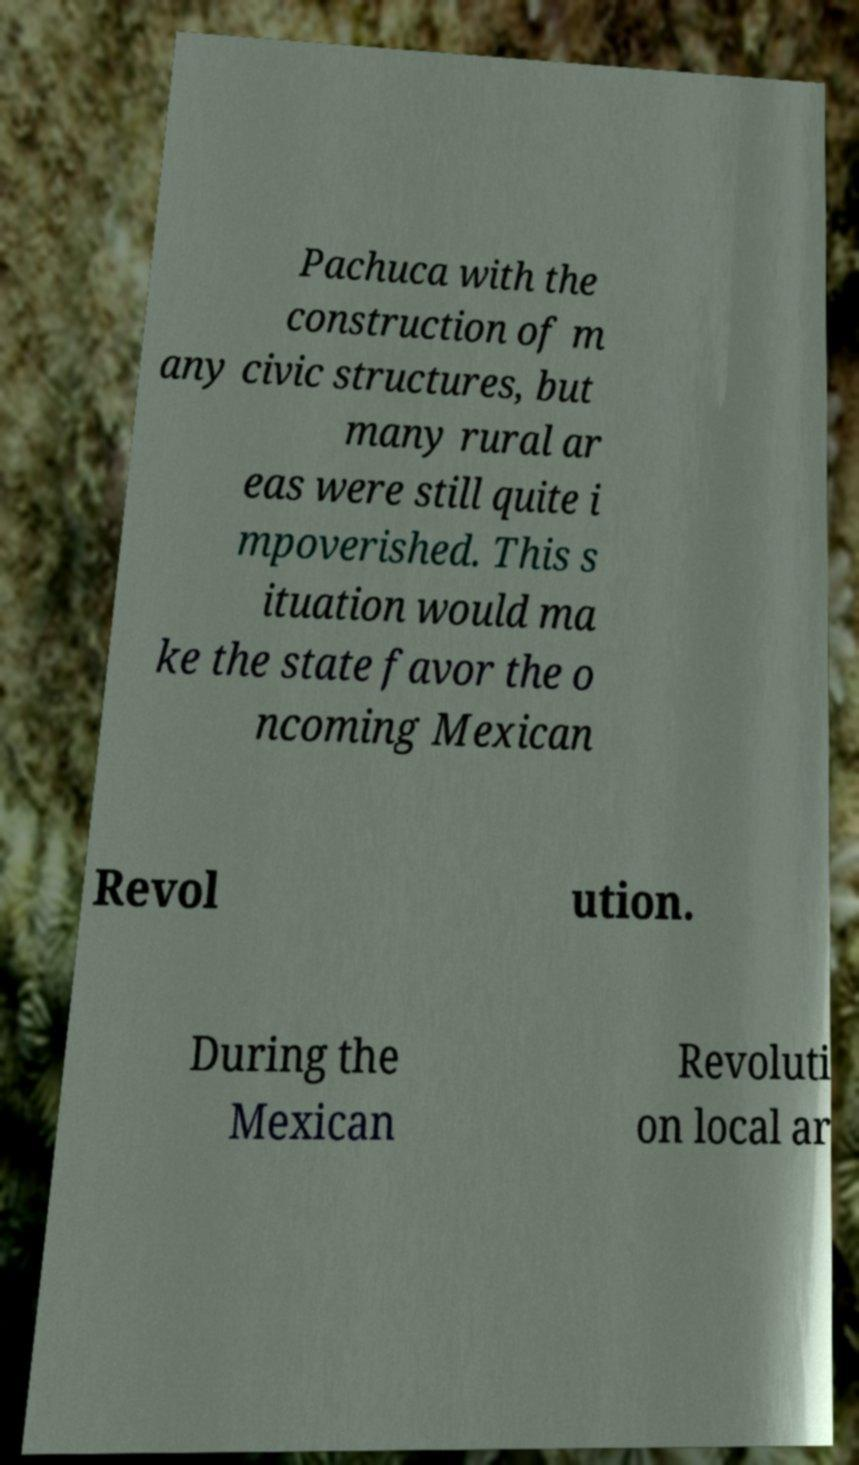Can you read and provide the text displayed in the image?This photo seems to have some interesting text. Can you extract and type it out for me? Pachuca with the construction of m any civic structures, but many rural ar eas were still quite i mpoverished. This s ituation would ma ke the state favor the o ncoming Mexican Revol ution. During the Mexican Revoluti on local ar 